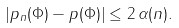<formula> <loc_0><loc_0><loc_500><loc_500>| p _ { n } ( \Phi ) - p ( \Phi ) | \leq 2 \, \alpha ( n ) .</formula> 